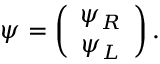Convert formula to latex. <formula><loc_0><loc_0><loc_500><loc_500>\psi = \left ( \begin{array} { c } { { \psi _ { R } } } \\ { { \psi _ { L } } } \end{array} \right ) .</formula> 